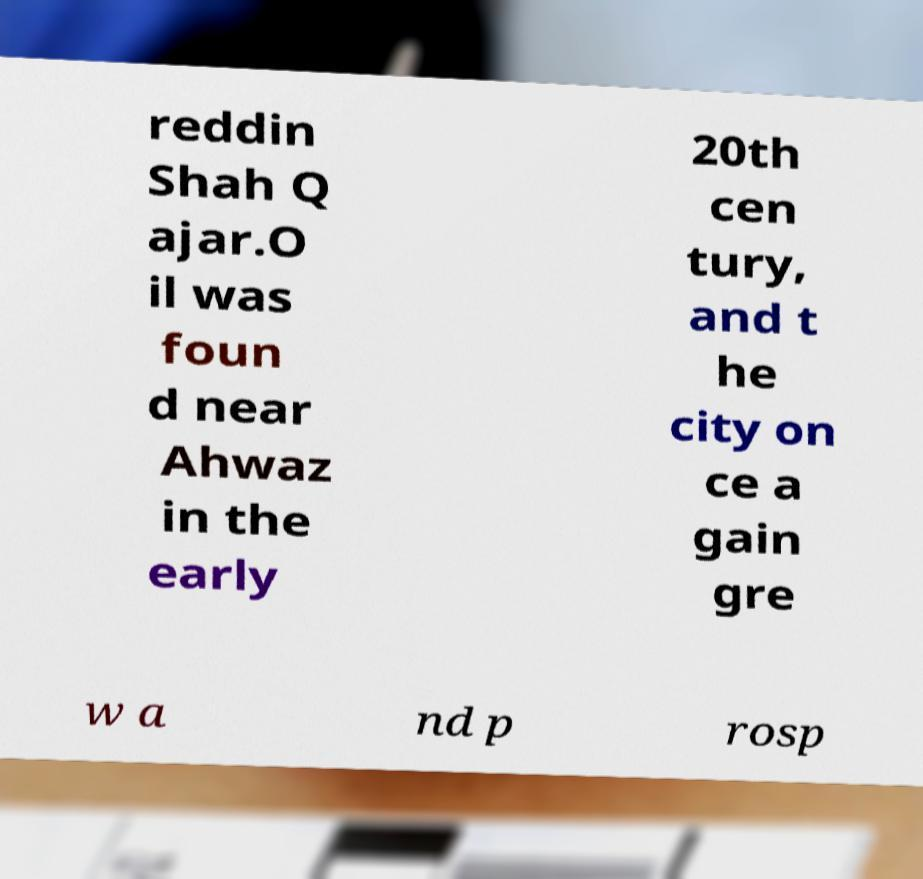Could you assist in decoding the text presented in this image and type it out clearly? reddin Shah Q ajar.O il was foun d near Ahwaz in the early 20th cen tury, and t he city on ce a gain gre w a nd p rosp 